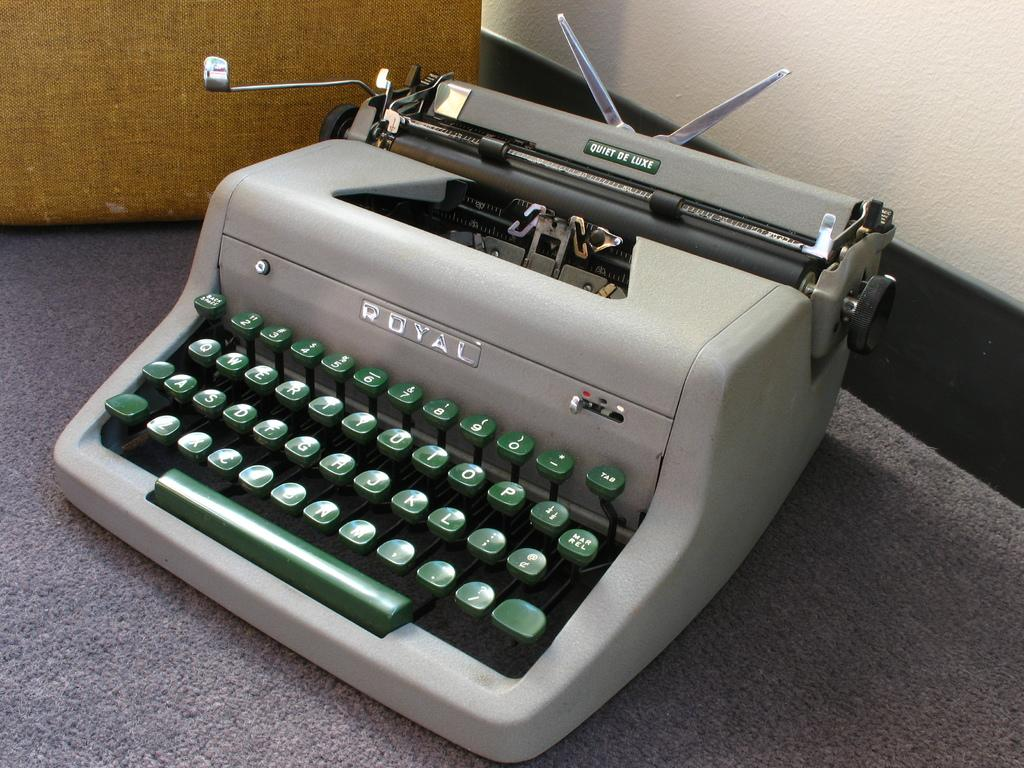<image>
Provide a brief description of the given image. A grey typewriter by royal with green colored keys. 